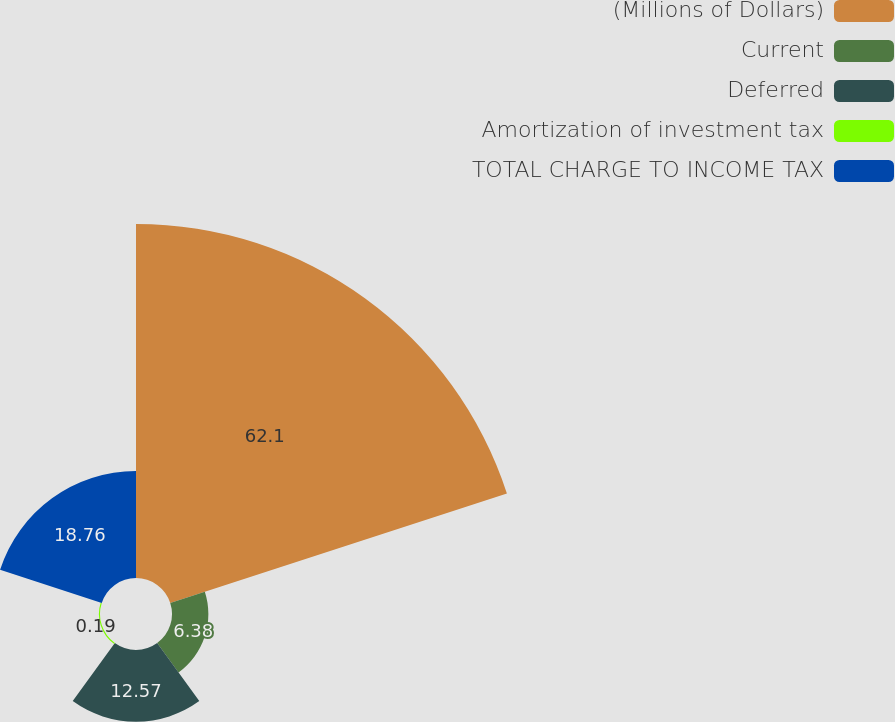Convert chart to OTSL. <chart><loc_0><loc_0><loc_500><loc_500><pie_chart><fcel>(Millions of Dollars)<fcel>Current<fcel>Deferred<fcel>Amortization of investment tax<fcel>TOTAL CHARGE TO INCOME TAX<nl><fcel>62.11%<fcel>6.38%<fcel>12.57%<fcel>0.19%<fcel>18.76%<nl></chart> 